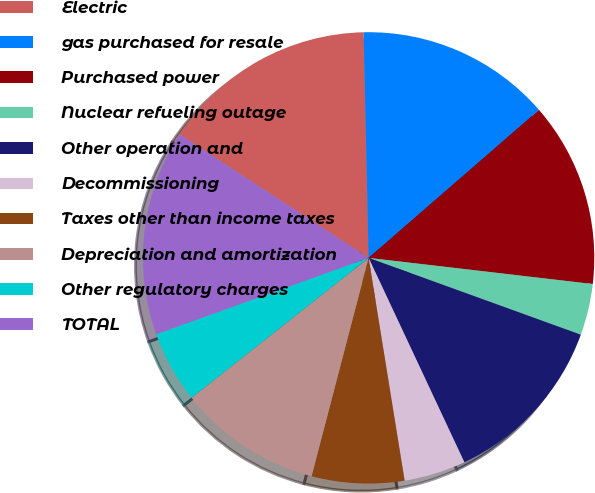Convert chart to OTSL. <chart><loc_0><loc_0><loc_500><loc_500><pie_chart><fcel>Electric<fcel>gas purchased for resale<fcel>Purchased power<fcel>Nuclear refueling outage<fcel>Other operation and<fcel>Decommissioning<fcel>Taxes other than income taxes<fcel>Depreciation and amortization<fcel>Other regulatory charges<fcel>TOTAL<nl><fcel>15.44%<fcel>13.97%<fcel>13.23%<fcel>3.68%<fcel>12.5%<fcel>4.42%<fcel>6.62%<fcel>10.29%<fcel>5.15%<fcel>14.7%<nl></chart> 